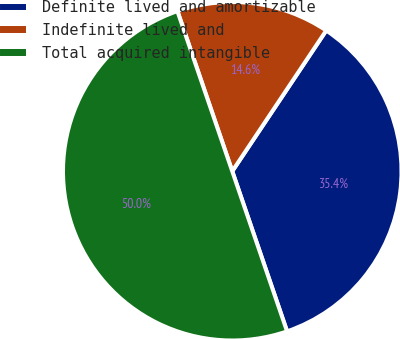Convert chart to OTSL. <chart><loc_0><loc_0><loc_500><loc_500><pie_chart><fcel>Definite lived and amortizable<fcel>Indefinite lived and<fcel>Total acquired intangible<nl><fcel>35.38%<fcel>14.62%<fcel>50.0%<nl></chart> 